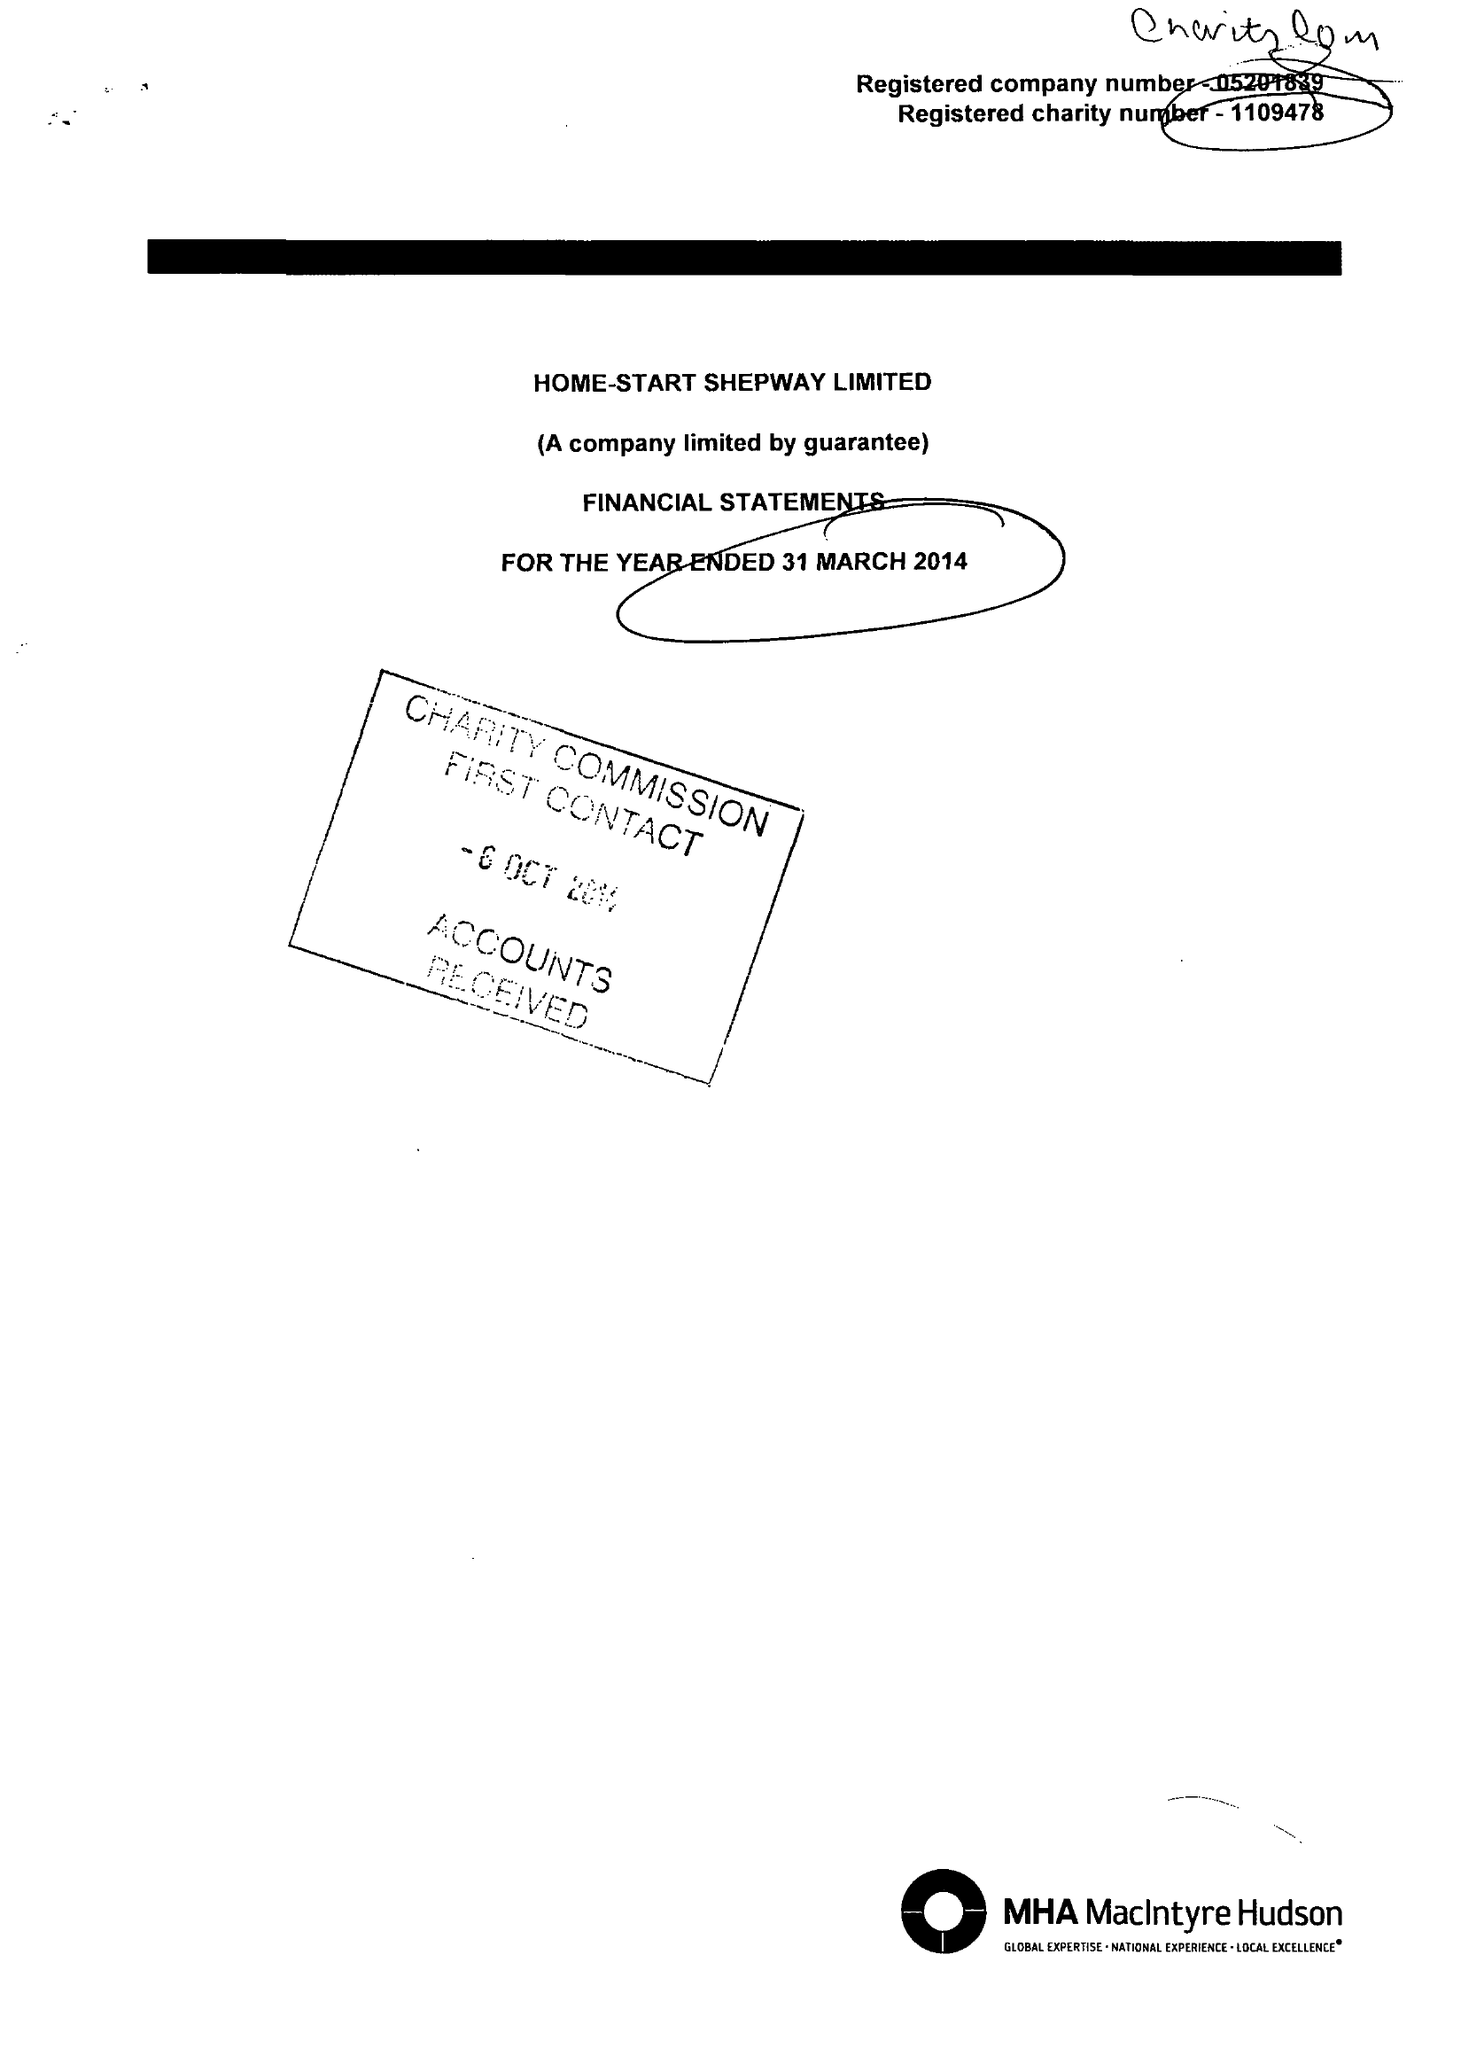What is the value for the report_date?
Answer the question using a single word or phrase. 2014-03-31 